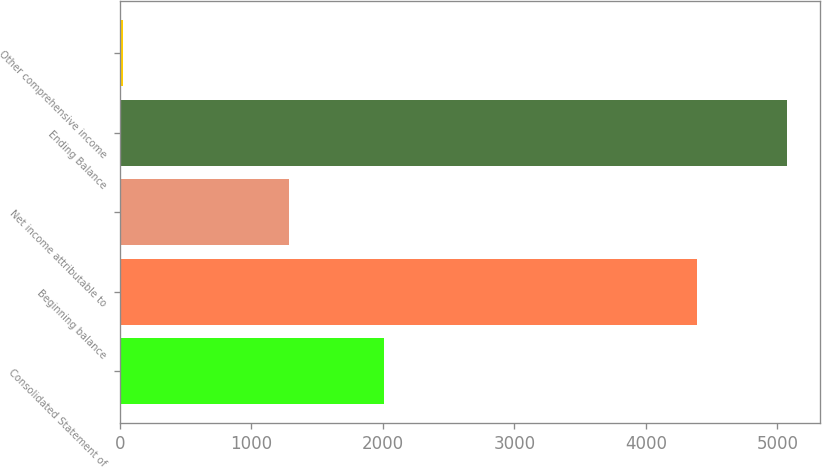<chart> <loc_0><loc_0><loc_500><loc_500><bar_chart><fcel>Consolidated Statement of<fcel>Beginning balance<fcel>Net income attributable to<fcel>Ending Balance<fcel>Other comprehensive income<nl><fcel>2010<fcel>4390<fcel>1287<fcel>5071<fcel>22<nl></chart> 